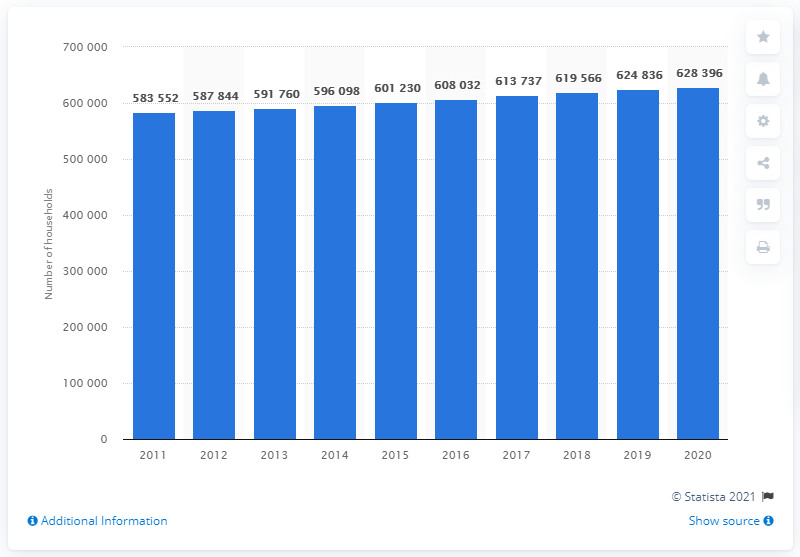Specify some key components in this picture. There are approximately 628,396 households in Sweden with two children. 